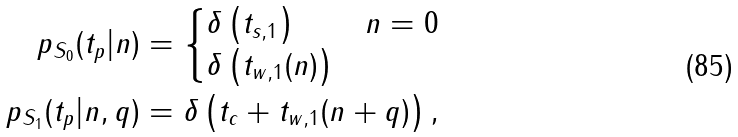<formula> <loc_0><loc_0><loc_500><loc_500>p _ { S _ { 0 } } ( t _ { p } | n ) & = \begin{cases} \delta \left ( t _ { s , 1 } \right ) & n = 0 \\ \delta \left ( t _ { w , 1 } ( n ) \right ) & \end{cases} \\ p _ { S _ { 1 } } ( t _ { p } | n , q ) & = \delta \left ( t _ { c } + t _ { w , 1 } ( n + q ) \right ) ,</formula> 